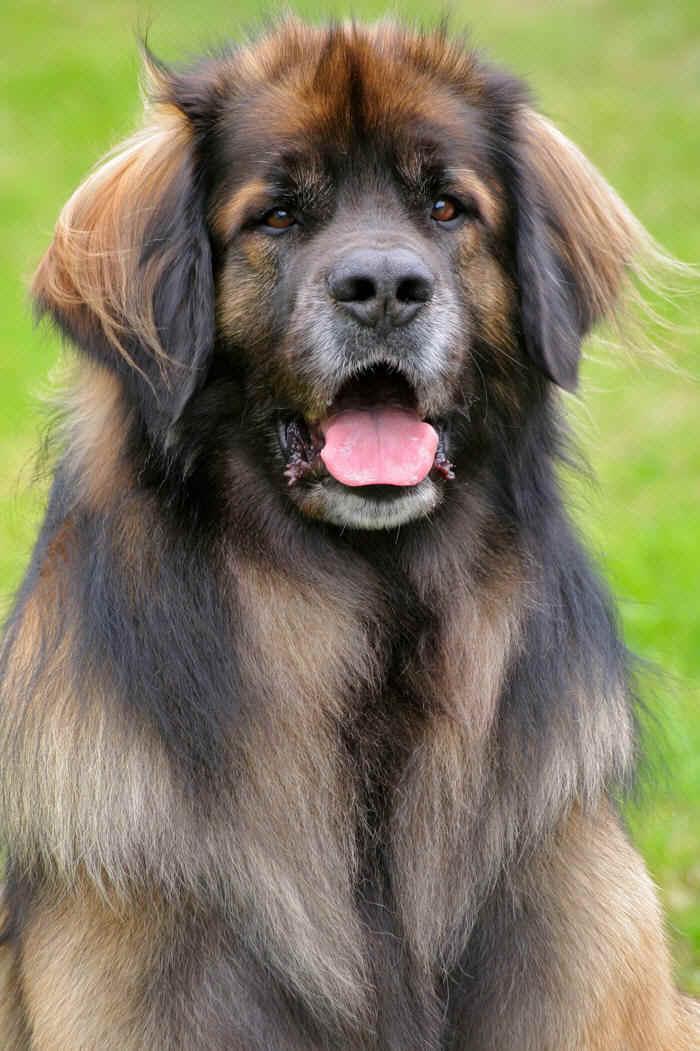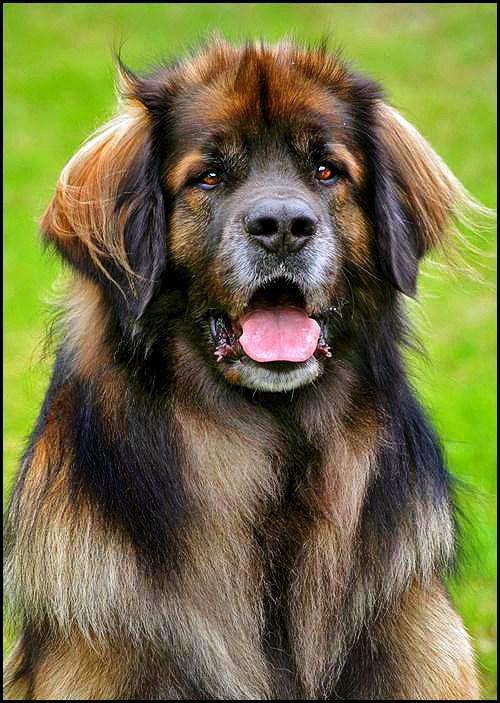The first image is the image on the left, the second image is the image on the right. Assess this claim about the two images: "The dog in the left image is looking towards the right with its tongue hanging out.". Correct or not? Answer yes or no. No. 